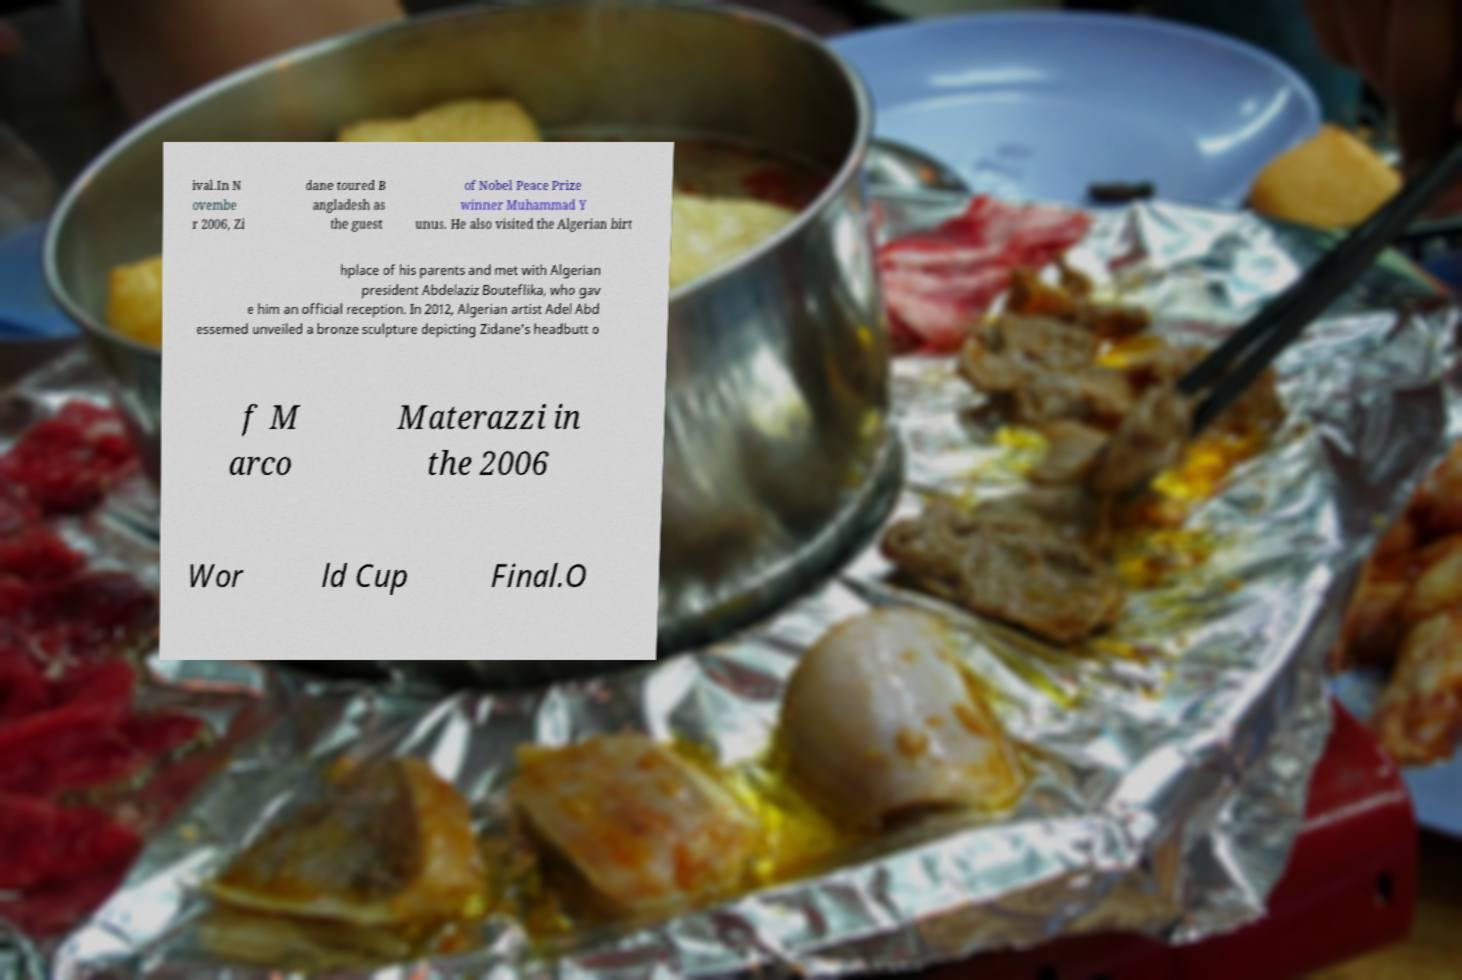Please read and relay the text visible in this image. What does it say? ival.In N ovembe r 2006, Zi dane toured B angladesh as the guest of Nobel Peace Prize winner Muhammad Y unus. He also visited the Algerian birt hplace of his parents and met with Algerian president Abdelaziz Bouteflika, who gav e him an official reception. In 2012, Algerian artist Adel Abd essemed unveiled a bronze sculpture depicting Zidane's headbutt o f M arco Materazzi in the 2006 Wor ld Cup Final.O 